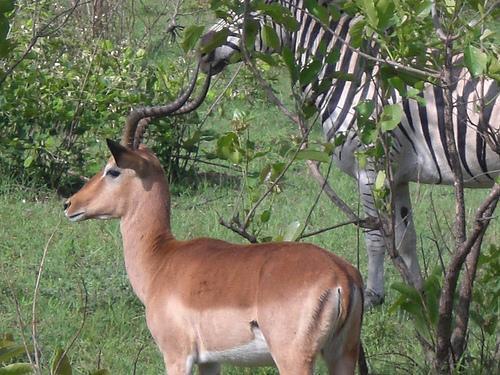How many animals are seen?
Give a very brief answer. 2. 